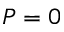Convert formula to latex. <formula><loc_0><loc_0><loc_500><loc_500>P = 0</formula> 